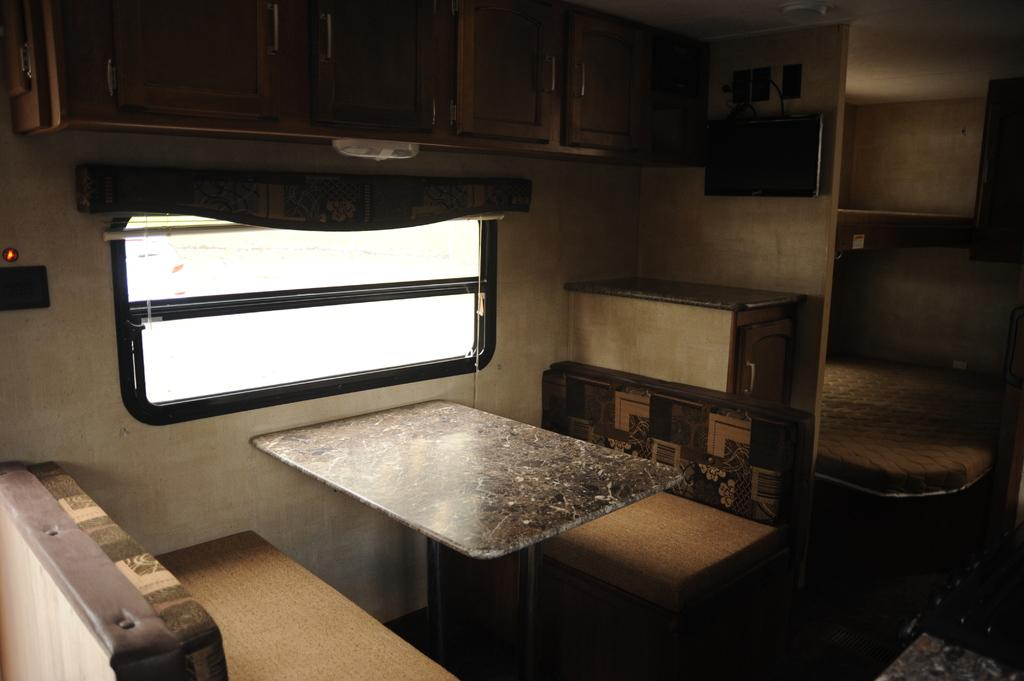What type of furniture is present in the image? There is a table, benches, and a bed in the image. What can be seen on the wall in the image? The wall is visible in the image. What type of storage furniture is present in the image? There are cupboards in the image. What type of electronic device is present in the image? There is a television in the image. What type of lighting fixture is present in the image? There is a light in the image. What can be seen through the window in the image? The window is visible in the image. What type of beast is roaming around the room in the image? There is no beast present in the image; it only features furniture, a wall, cupboards, a television, a light, and a window. 